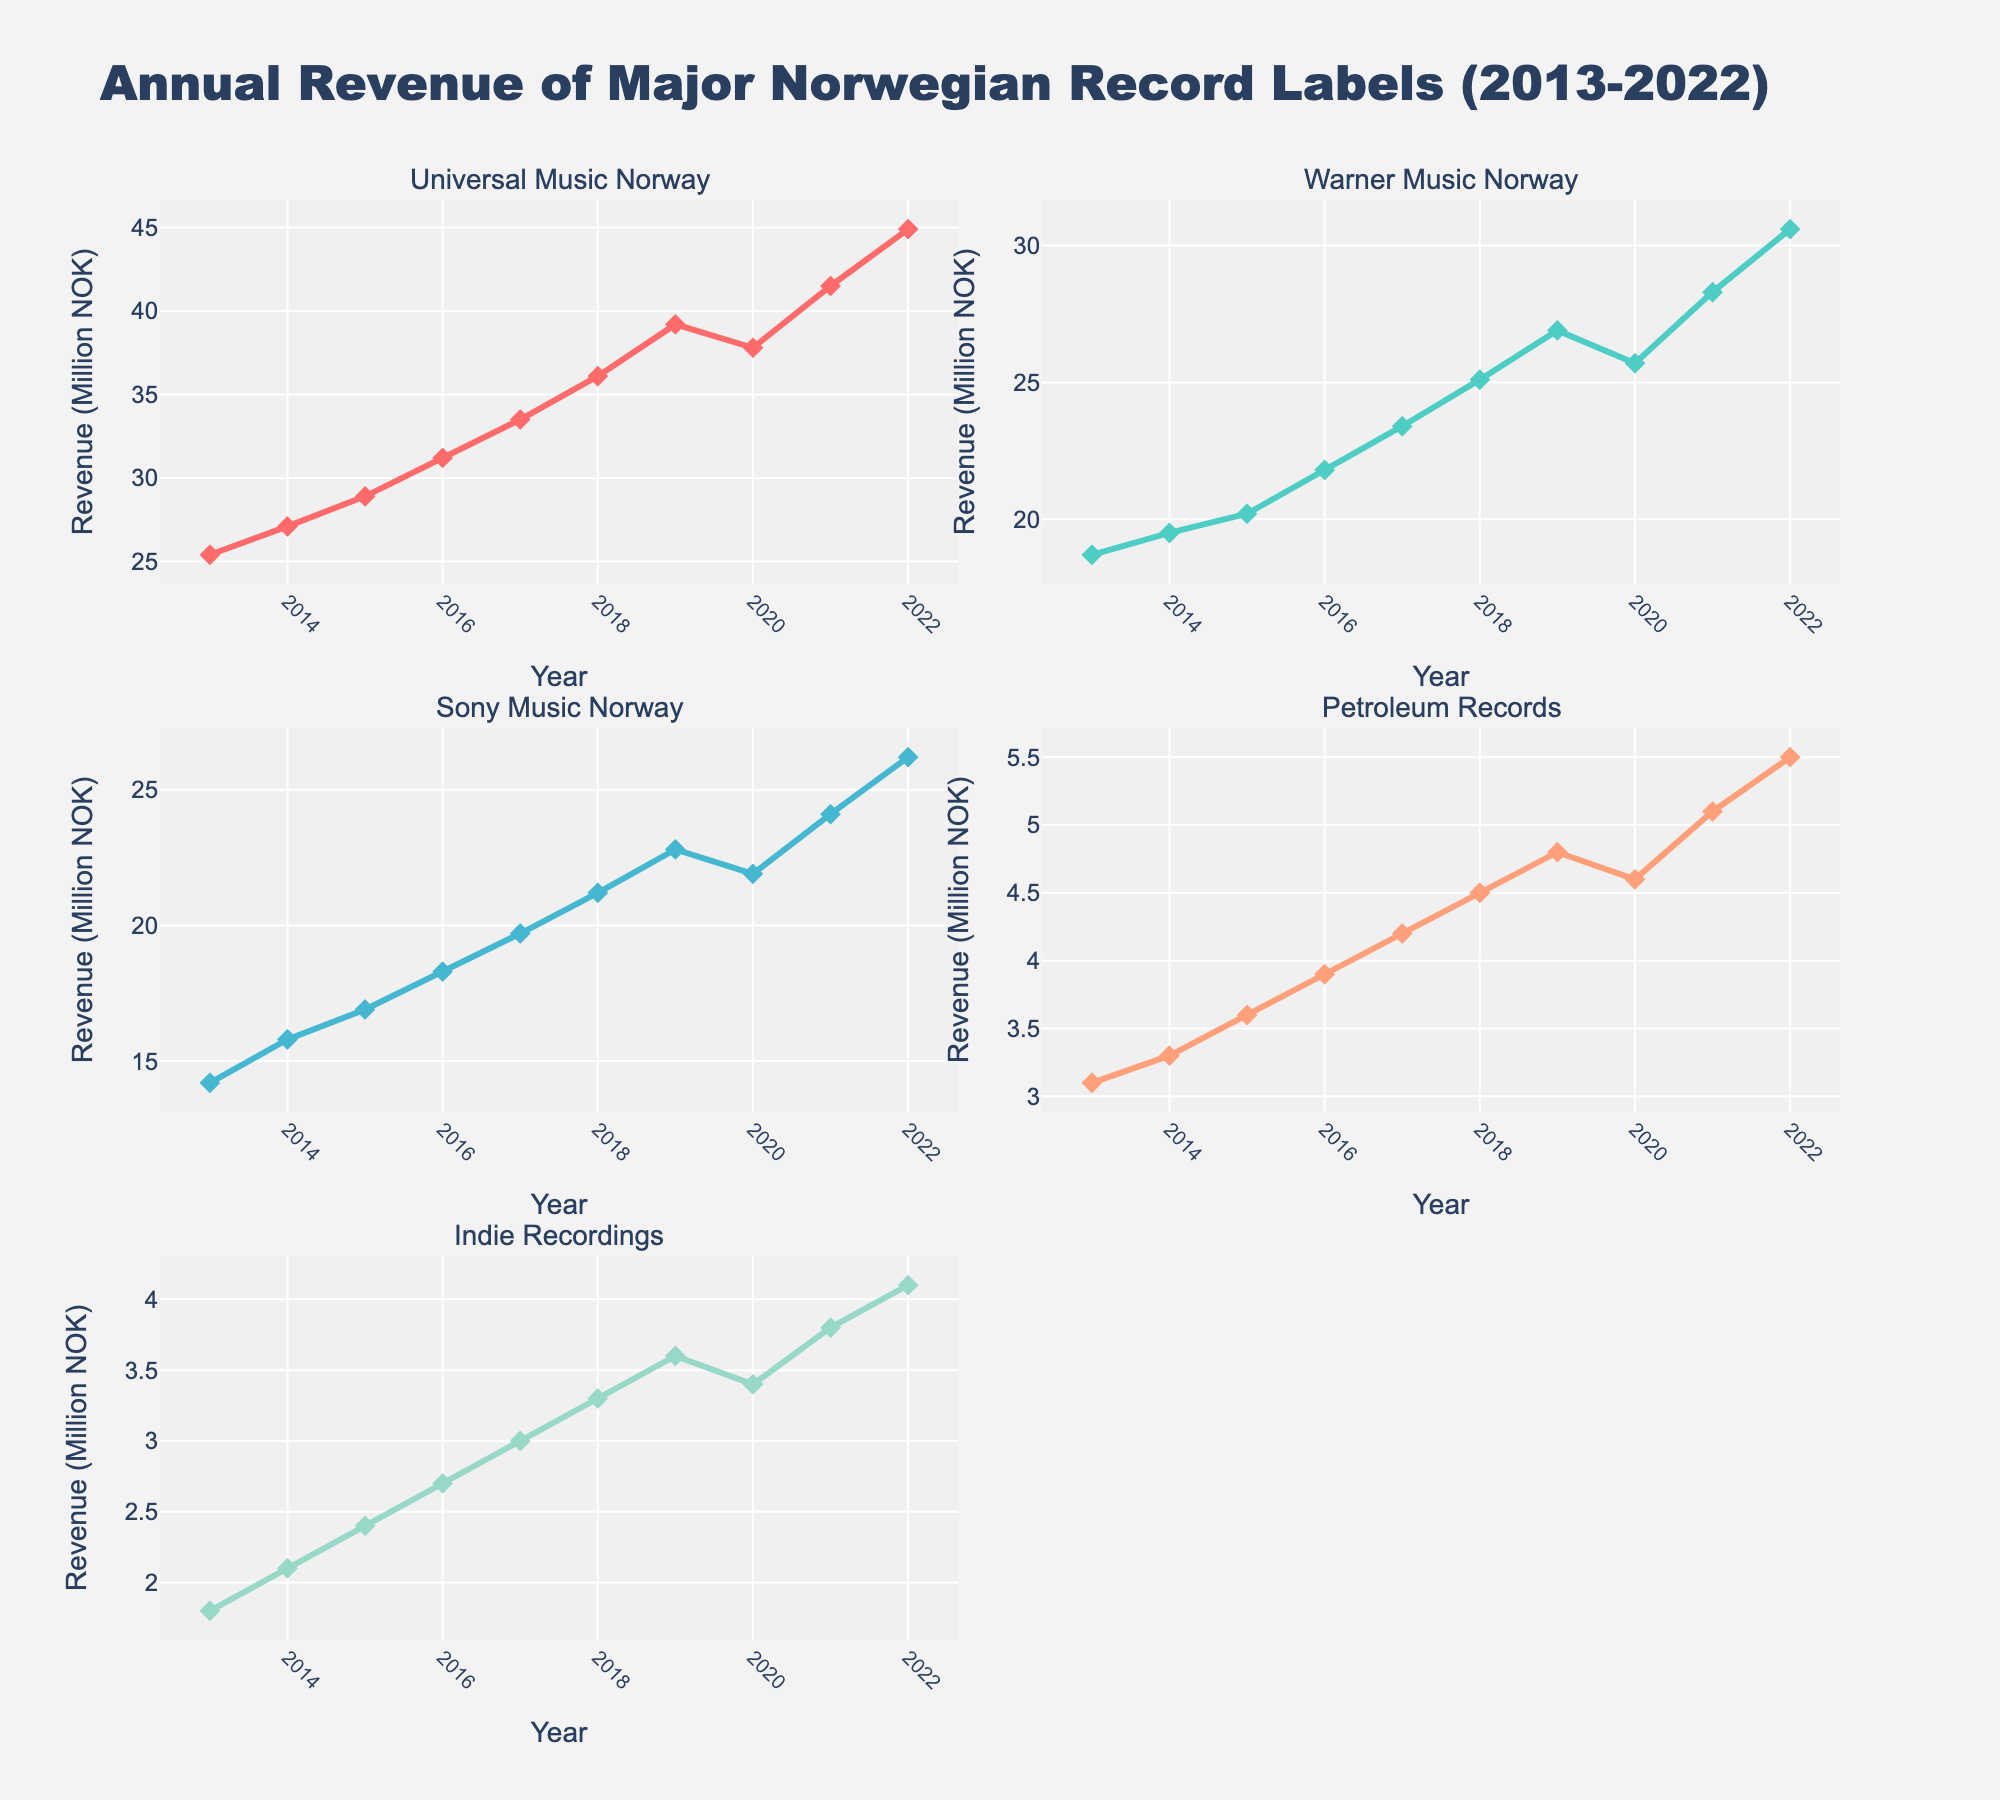What is the title of the figure? The title of the figure can be found at the top of the chart and usually summarizes the overall content or subject matter.
Answer: Annual Revenue of Major Norwegian Record Labels (2013-2022) Which record label had the highest revenue in 2022? By looking at the data points for 2022 in each subplot, it's clear that Universal Music Norway's line is the highest.
Answer: Universal Music Norway How many record labels are compared in this figure? Each subplot represents a different record label, and counting the subplots gives the total number of labels.
Answer: 5 Which record label had a decline in revenue from 2019 to 2020? By examining the trend lines from 2019 to 2020 in each subplot, we can see that Universal Music Norway and Warner Music Norway show a decline during this period.
Answer: Universal Music Norway and Warner Music Norway What was the total revenue for Indie Recordings in the first and last years shown? Look at the revenue values for Indie Recordings in 2013 and 2022: 1.8 and 4.1 million NOK respectively. Adding these gives 1.8 + 4.1.
Answer: 5.9 million NOK Which record label had the most steady increase in revenue over the decade? By observing the slopes of the lines in each subplot, Sony Music Norway shows the most consistent upward trend with no declines.
Answer: Sony Music Norway What was the approximate average revenue of Petroleum Records over the decade? Add the revenue values for Petroleum Records from 2013 to 2022 and divide by the number of years (10): (3.1 + 3.3 + 3.6 + 3.9 + 4.2 + 4.5 + 4.8 + 4.6 + 5.1 + 5.5) / 10.
Answer: 4.26 million NOK In which year did all record labels except Indie Recordings see an increase in revenue? Look for the year where Universal Music Norway, Warner Music Norway, Sony Music Norway, and Petroleum Records' revenue increased while Indie Recordings' revenue stayed the same or decreased. This happened in 2015.
Answer: 2015 Which two record labels had the closest revenue values in any year, and what was the year? Comparing the values across years and labels reveals that in 2013, Warner Music Norway (18.7) and Sony Music Norway (14.2) had the closest revenues (difference of 4.5).
Answer: Warner Music Norway and Sony Music Norway, 2013 Which label saw the largest single-year revenue increase, and in which year did this occur? By observing the change in revenue from year to year for each label, Universal Music Norway had the largest increase from 2021 to 2022, going from 41.5 to 44.9 million NOK.
Answer: Universal Music Norway, 2021-2022 